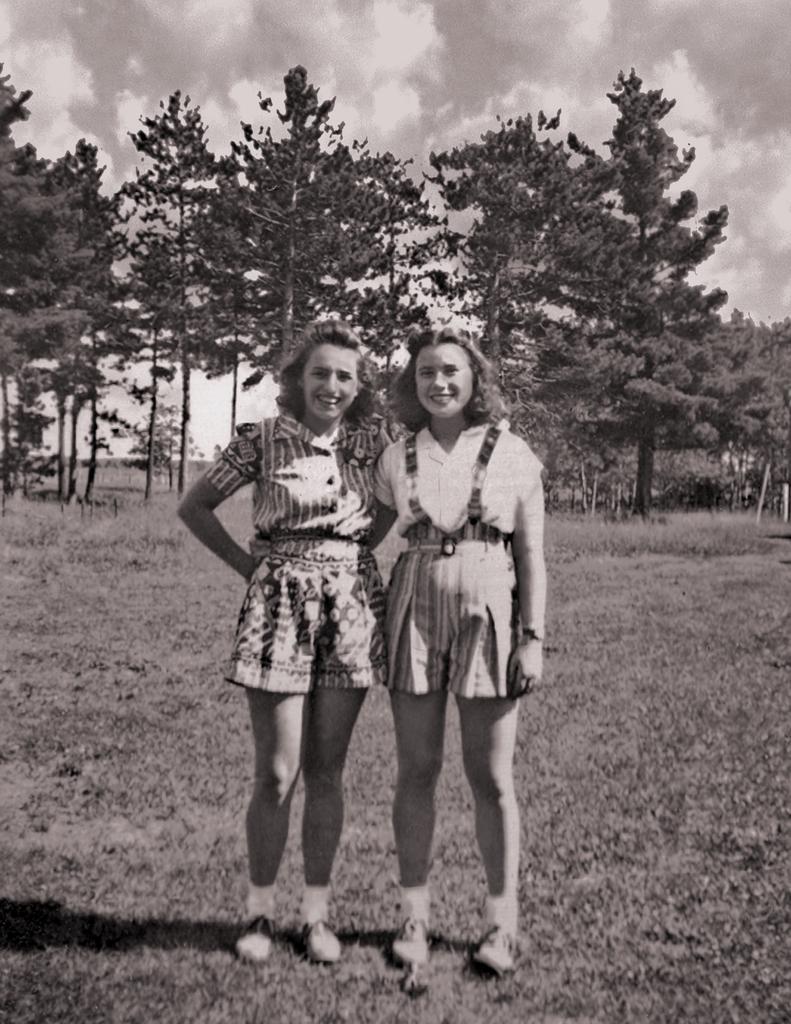How would you summarize this image in a sentence or two? In this picture I can see 2 women in the front, who are standing and I see that both of them are smiling. In the background I see number of trees and the sky. I can also see that this is a black and white picture. 